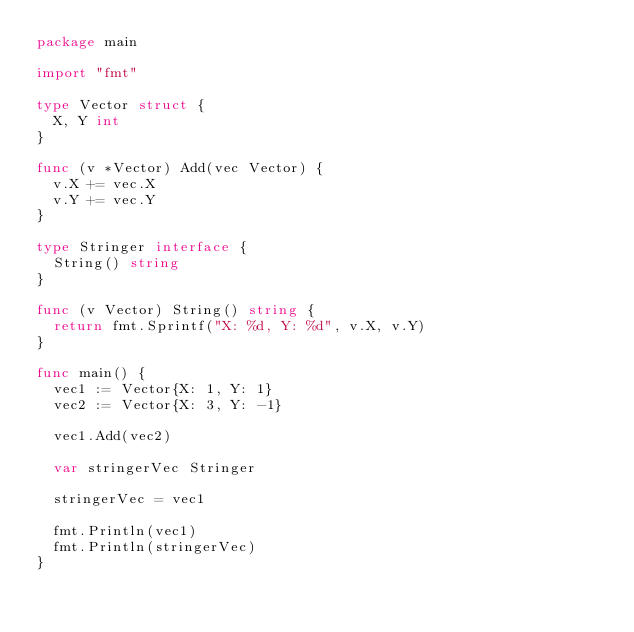Convert code to text. <code><loc_0><loc_0><loc_500><loc_500><_Go_>package main

import "fmt"

type Vector struct {
	X, Y int
}

func (v *Vector) Add(vec Vector) {
	v.X += vec.X
	v.Y += vec.Y
}

type Stringer interface {
	String() string
}

func (v Vector) String() string {
	return fmt.Sprintf("X: %d, Y: %d", v.X, v.Y)
}

func main() {
	vec1 := Vector{X: 1, Y: 1}
	vec2 := Vector{X: 3, Y: -1}

	vec1.Add(vec2)

	var stringerVec Stringer

	stringerVec = vec1

	fmt.Println(vec1)
	fmt.Println(stringerVec)
}
</code> 